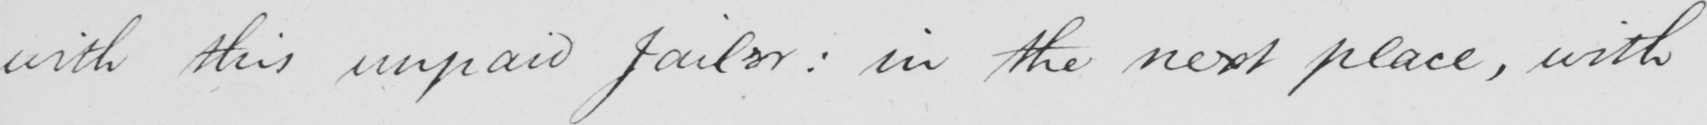Please transcribe the handwritten text in this image. with this unpaid Jailer :  in the next place , with 